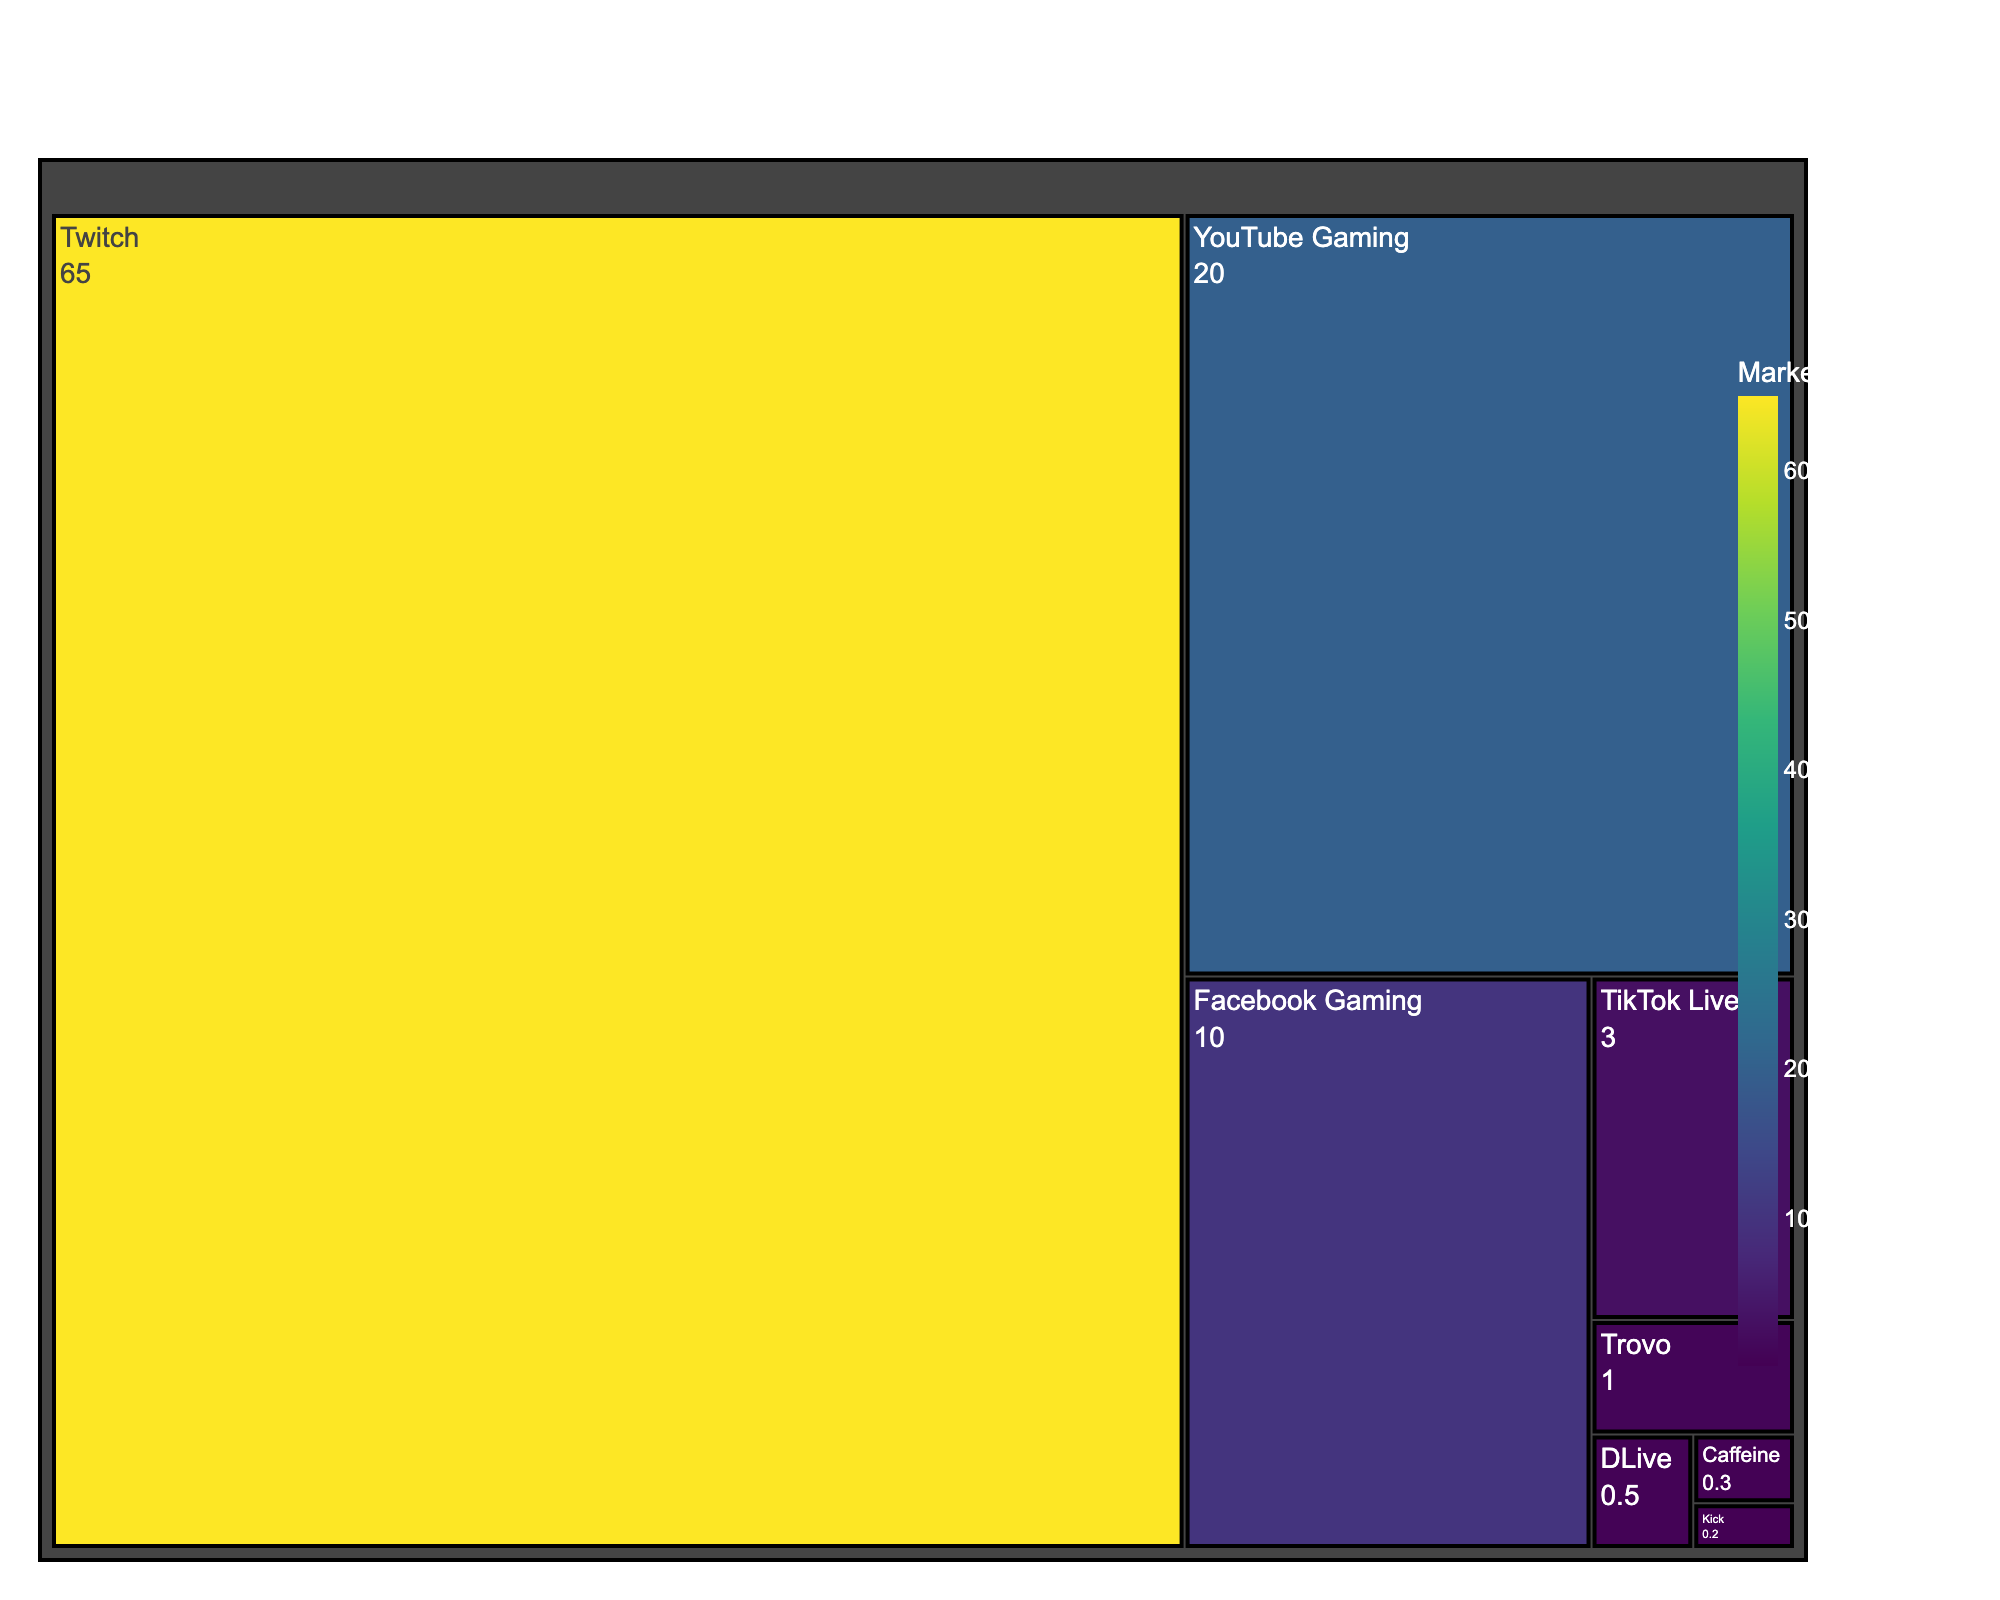What is the title of the treemap? The title of the treemap is displayed prominently at the top of the figure. By reading it, we identify the theme of the visual representation.
Answer: Streaming Platforms Market Share in Gaming Industry Which streaming platform has the highest market share? By observing the largest segment in the treemap, we can see that it is labeled with the name of the streaming platform that has the highest market share.
Answer: Twitch What is the combined market share of TikTok Live and Trovo? To find the combined market share, we locate TikTok Live and Trovo in the treemap and add their market share values: 3% (TikTok Live) + 1% (Trovo) = 4%.
Answer: 4% How does YouTube Gaming's market share compare to Facebook Gaming’s? By comparing the sizes of the segments and their labels, we find that YouTube Gaming has a higher market share of 20%, compared to Facebook Gaming’s 10%.
Answer: YouTube Gaming has a higher market share than Facebook Gaming Identify the platforms with a market share of 1% or less. By examining the segments with labels indicating 1% or less market share, we identify Trovo (1%), DLive (0.5%), Caffeine (0.3%), and Kick (0.2%).
Answer: Trovo, DLive, Caffeine, Kick What is the total market share of platforms with less than 1% share? We sum the market shares of platforms with less than 1%: DLive (0.5%) + Caffeine (0.3%) + Kick (0.2%) = 1%.
Answer: 1% Which two platforms, when combined, have a market share closest to Facebook Gaming’s? We find the pairs of platforms and compare their combined market shares to Facebook Gaming’s 10%. The closest combination is TikTok Live (3%) and DLive (0.5%) + Caffeine (0.3%) + Kick (0.2%) = 1% in total 4%. So TikTok Live + Facebook Gaming itself.
Answer: TikTok Live and other together equals Facebook gaming itself How much larger is Twitch’s market share compared to YouTube Gaming’s? We subtract YouTube Gaming’s market share of 20% from Twitch’s market share of 65%: 65% - 20% = 45%.
Answer: 45% What percent of the market share do Twitch, YouTube Gaming, and Facebook Gaming represent together? Adding their individual market shares: 65% (Twitch) + 20% (YouTube Gaming) + 10% (Facebook Gaming) = 95%.
Answer: 95% What is the difference between the market share of Facebook Gaming and TikTok Live? Subtract TikTok Live's market share (3%) from Facebook Gaming’s market share (10%): 10% - 3% = 7%.
Answer: 7% 